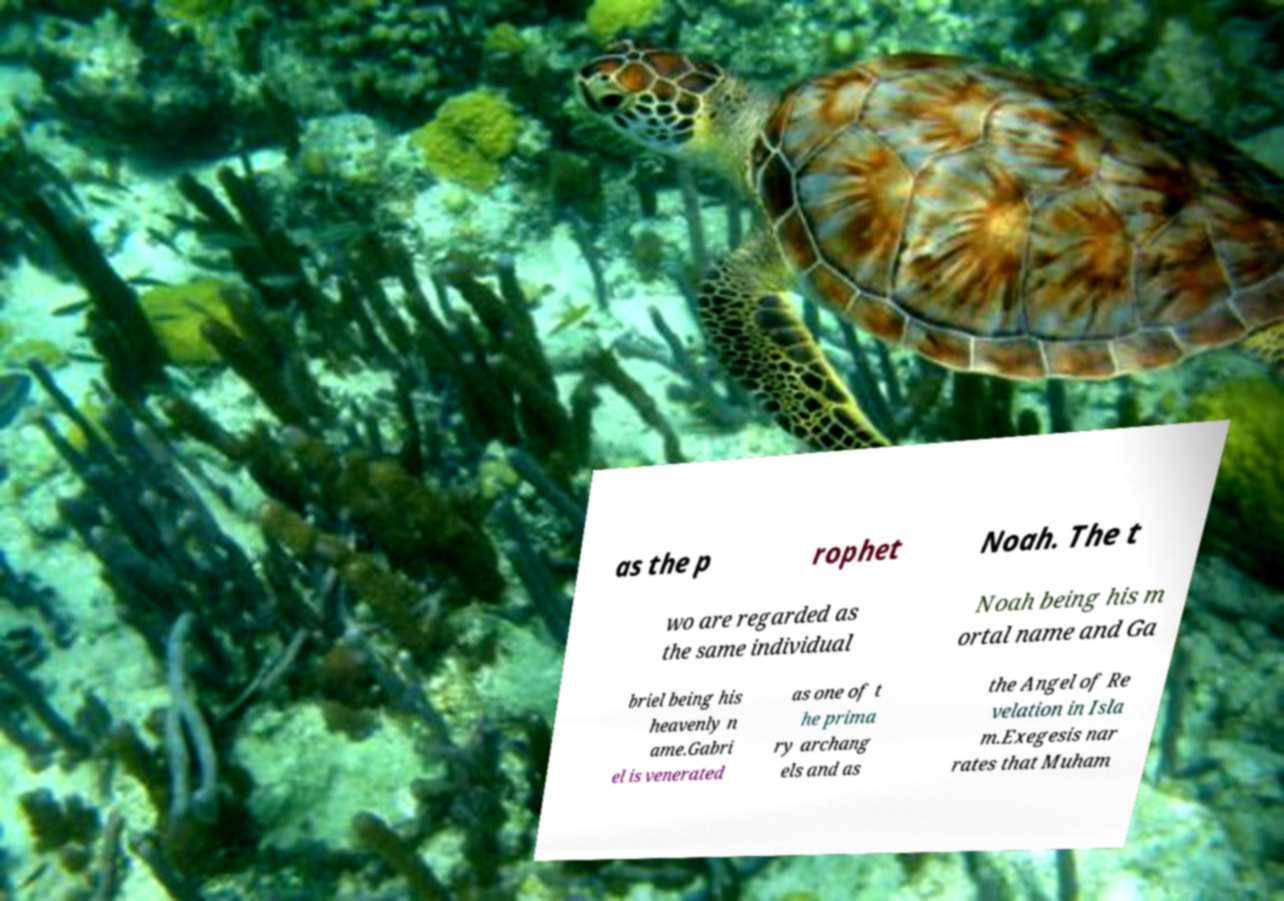What messages or text are displayed in this image? I need them in a readable, typed format. as the p rophet Noah. The t wo are regarded as the same individual Noah being his m ortal name and Ga briel being his heavenly n ame.Gabri el is venerated as one of t he prima ry archang els and as the Angel of Re velation in Isla m.Exegesis nar rates that Muham 